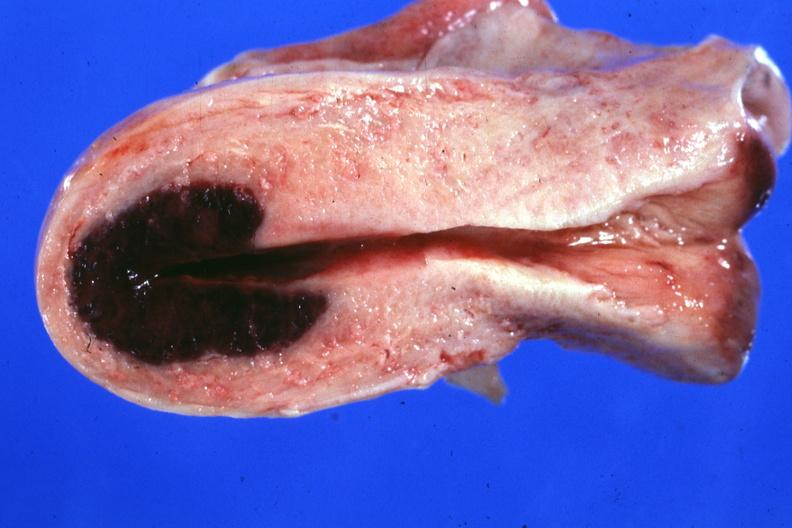s cachexia present?
Answer the question using a single word or phrase. No 